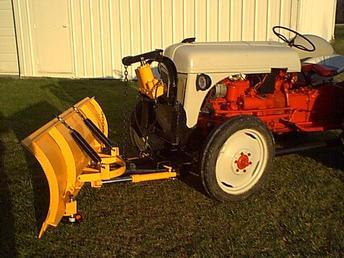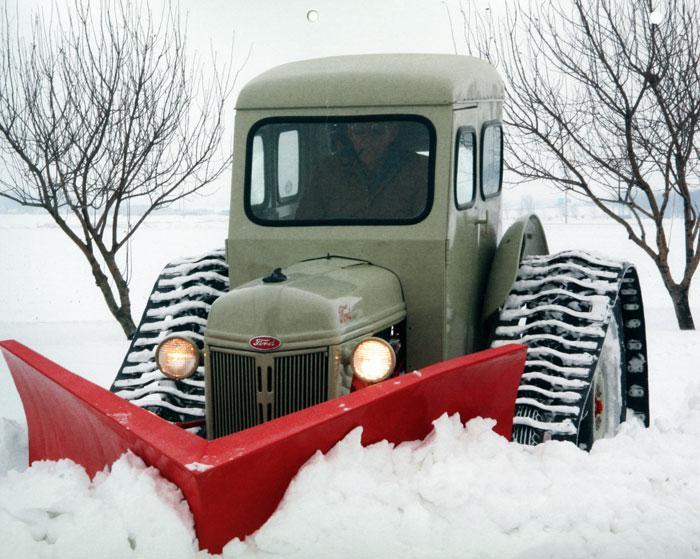The first image is the image on the left, the second image is the image on the right. For the images shown, is this caption "Right image shows a tractor with plow on a snow-covered ground." true? Answer yes or no. Yes. The first image is the image on the left, the second image is the image on the right. Considering the images on both sides, is "there are two trees in the image on the right." valid? Answer yes or no. Yes. 